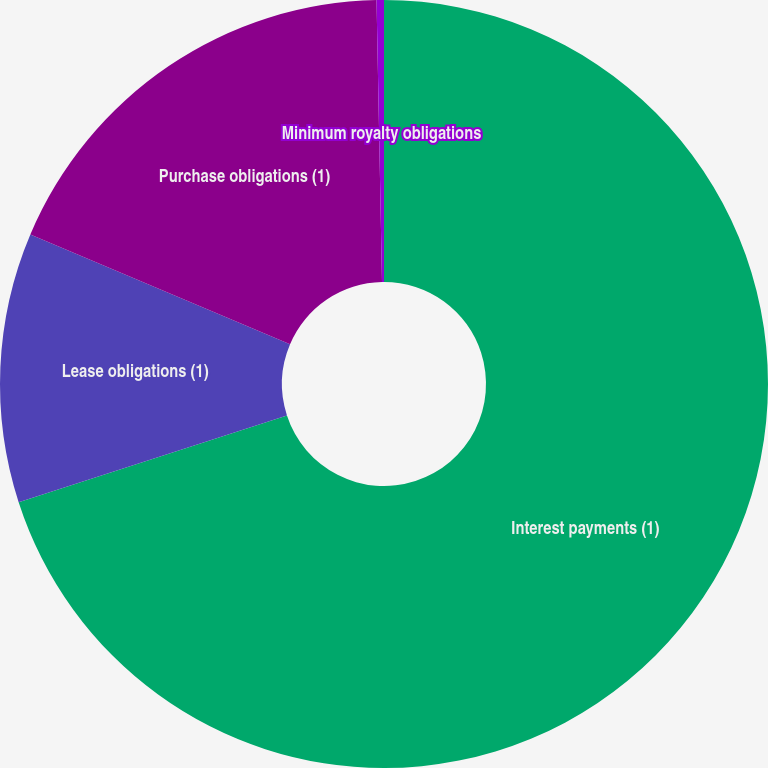Convert chart. <chart><loc_0><loc_0><loc_500><loc_500><pie_chart><fcel>Interest payments (1)<fcel>Lease obligations (1)<fcel>Purchase obligations (1)<fcel>Minimum royalty obligations<nl><fcel>70.02%<fcel>11.35%<fcel>18.32%<fcel>0.31%<nl></chart> 